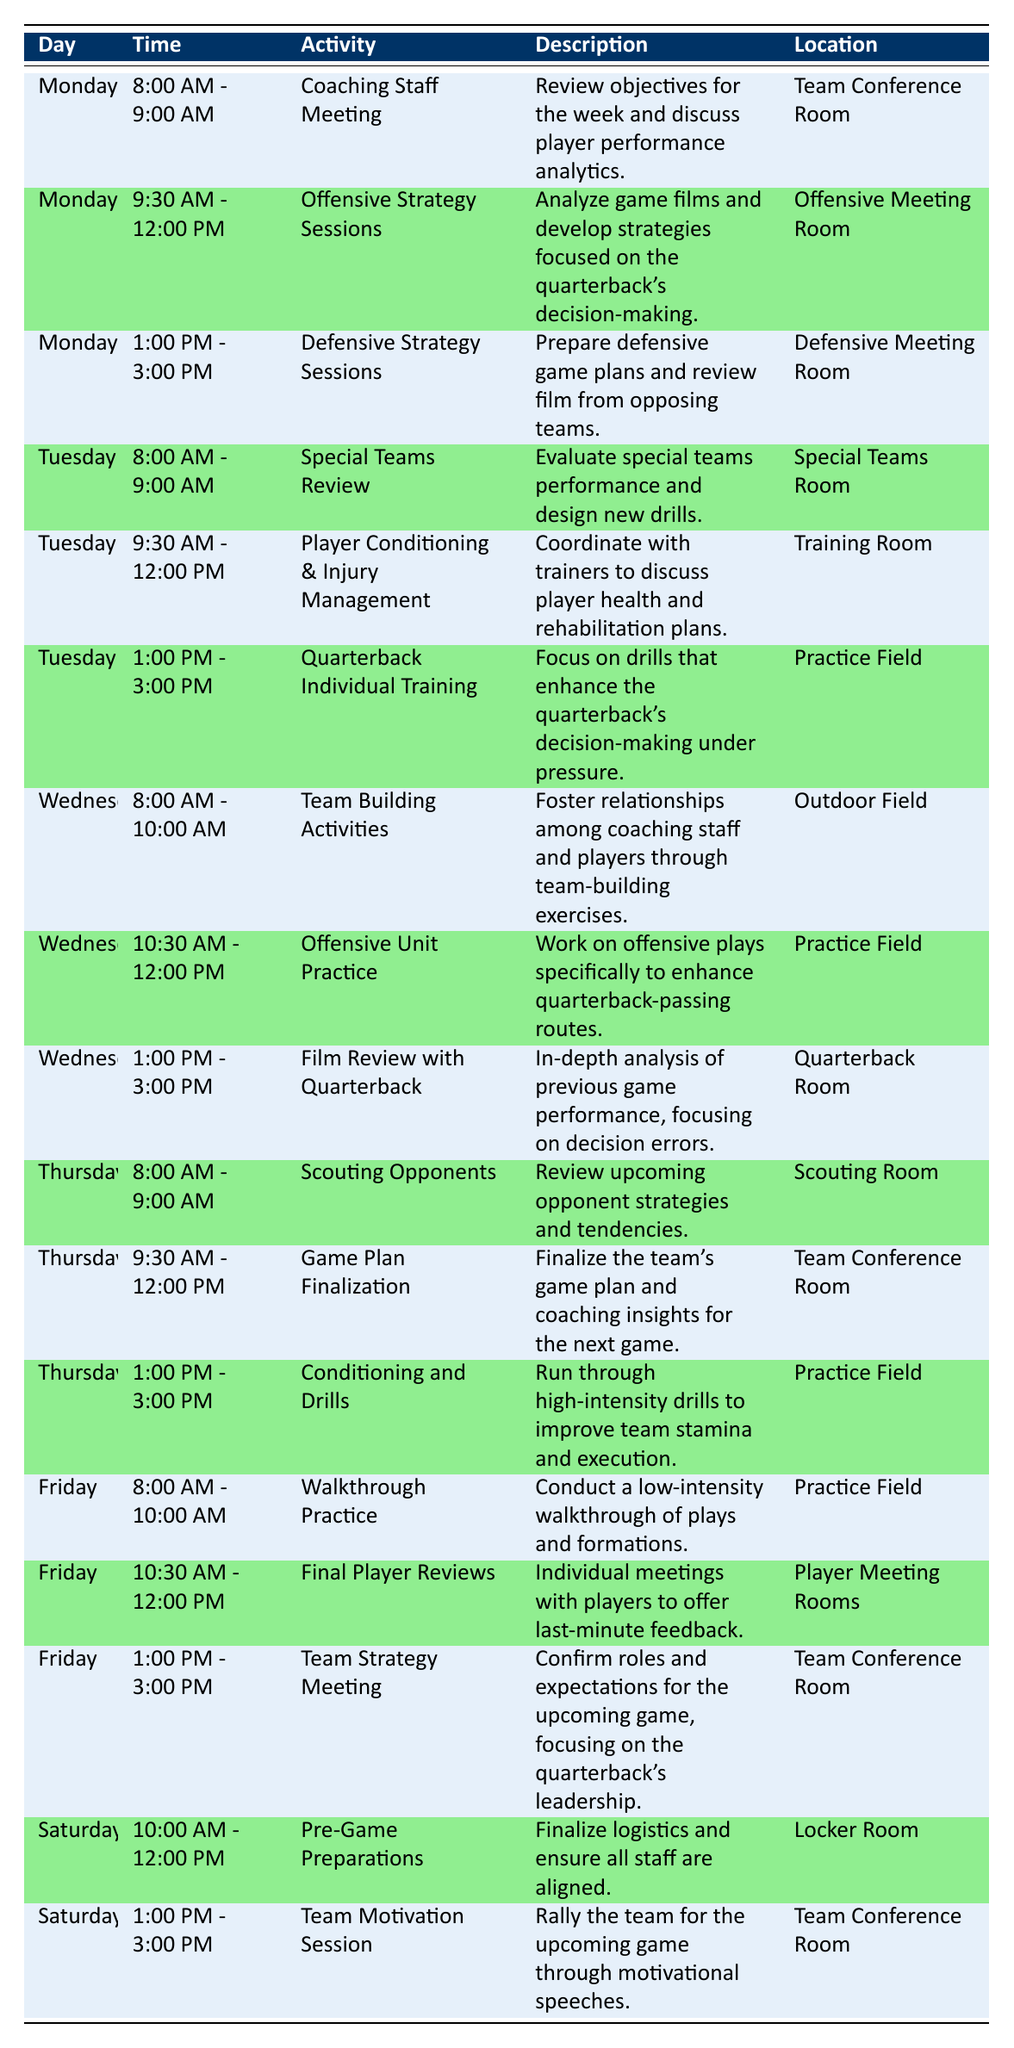What is the location for the Offensive Strategy Sessions on Monday? The table indicates that the Offensive Strategy Sessions on Monday are held in the Offensive Meeting Room.
Answer: Offensive Meeting Room What time is the Quarterback Individual Training scheduled on Tuesday? According to the table, the Quarterback Individual Training is scheduled from 1:00 PM to 3:00 PM on Tuesday.
Answer: 1:00 PM - 3:00 PM Is there a Team Strategy Meeting scheduled on Friday? The table shows that there is indeed a Team Strategy Meeting on Friday from 1:00 PM to 3:00 PM, making the statement true.
Answer: Yes How many activities take place on Wednesday? The table lists three activities on Wednesday: Team Building Activities, Offensive Unit Practice, and Film Review with Quarterback, totaling to three activities.
Answer: 3 What are the two activities scheduled back-to-back on Thursday? Referring to the table, Thursday has two back-to-back activities from 8:00 AM to 9:00 AM (Scouting Opponents) and from 9:30 AM to 12:00 PM (Game Plan Finalization).
Answer: Scouting Opponents and Game Plan Finalization On which days do the Coaching Staff Meetings occur? The schedule shows that Coaching Staff Meetings are happening only on Monday, so it occurs solely on that day.
Answer: Monday What is the total duration of the activities scheduled on Tuesday? Adding the durations of the activities on Tuesday: Special Teams Review (1 hour) + Player Conditioning & Injury Management (2.5 hours) + Quarterback Individual Training (2 hours) gives a total of 5 hours for Tuesday's activities.
Answer: 5 hours How does the timing of the Defensive Strategy Sessions on Monday compare to the other sessions on the same day? Defensive Strategy Sessions run from 1:00 PM to 3:00 PM on Monday, occurring after the Offensive Strategy Sessions, which last from 9:30 AM to 12:00 PM. This means there is a lunch break between both sessions.
Answer: After Offensive Strategy Sessions What is the focus of the Film Review with Quarterback on Wednesday? The Film Review with Quarterback focuses on analyzing previous game performance with a specific emphasis on decision errors made during the game, as mentioned in the description of the activity.
Answer: Decision errors analysis 